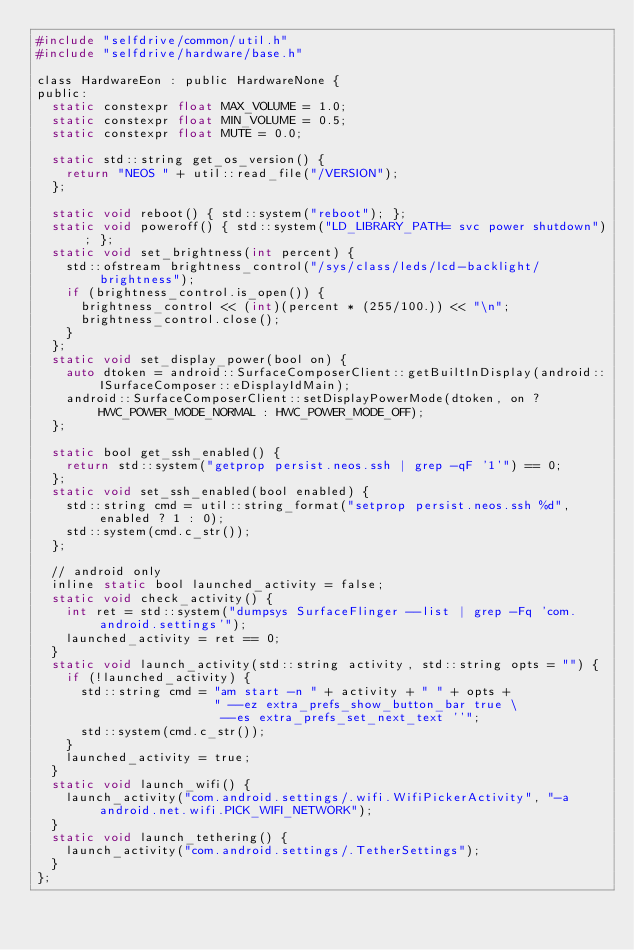Convert code to text. <code><loc_0><loc_0><loc_500><loc_500><_C_>#include "selfdrive/common/util.h"
#include "selfdrive/hardware/base.h"

class HardwareEon : public HardwareNone {
public:
  static constexpr float MAX_VOLUME = 1.0;
  static constexpr float MIN_VOLUME = 0.5;
  static constexpr float MUTE = 0.0;

  static std::string get_os_version() {
    return "NEOS " + util::read_file("/VERSION");
  };

  static void reboot() { std::system("reboot"); };
  static void poweroff() { std::system("LD_LIBRARY_PATH= svc power shutdown"); };
  static void set_brightness(int percent) {
    std::ofstream brightness_control("/sys/class/leds/lcd-backlight/brightness");
    if (brightness_control.is_open()) {
      brightness_control << (int)(percent * (255/100.)) << "\n";
      brightness_control.close();
    }
  };
  static void set_display_power(bool on) {
    auto dtoken = android::SurfaceComposerClient::getBuiltInDisplay(android::ISurfaceComposer::eDisplayIdMain);
    android::SurfaceComposerClient::setDisplayPowerMode(dtoken, on ? HWC_POWER_MODE_NORMAL : HWC_POWER_MODE_OFF);
  };

  static bool get_ssh_enabled() {
    return std::system("getprop persist.neos.ssh | grep -qF '1'") == 0;
  };
  static void set_ssh_enabled(bool enabled) {
    std::string cmd = util::string_format("setprop persist.neos.ssh %d", enabled ? 1 : 0);
    std::system(cmd.c_str());
  };

  // android only
  inline static bool launched_activity = false;
  static void check_activity() {
    int ret = std::system("dumpsys SurfaceFlinger --list | grep -Fq 'com.android.settings'");
    launched_activity = ret == 0;
  }
  static void launch_activity(std::string activity, std::string opts = "") {
    if (!launched_activity) {
      std::string cmd = "am start -n " + activity + " " + opts +
                        " --ez extra_prefs_show_button_bar true \
                         --es extra_prefs_set_next_text ''";
      std::system(cmd.c_str());
    }
    launched_activity = true;
  }
  static void launch_wifi() {
    launch_activity("com.android.settings/.wifi.WifiPickerActivity", "-a android.net.wifi.PICK_WIFI_NETWORK");
  }
  static void launch_tethering() {
    launch_activity("com.android.settings/.TetherSettings");
  }
};
</code> 